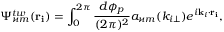Convert formula to latex. <formula><loc_0><loc_0><loc_500><loc_500>\Psi _ { \varkappa m } ^ { t w } ( r _ { i } ) = \int _ { 0 } ^ { 2 \pi } \frac { d \phi _ { p } } { ( 2 \pi ) ^ { 2 } } a _ { \varkappa m } ( k _ { i \bot } ) e ^ { i k _ { i } \cdot r _ { i } } ,</formula> 